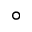<formula> <loc_0><loc_0><loc_500><loc_500>^ { \circ }</formula> 